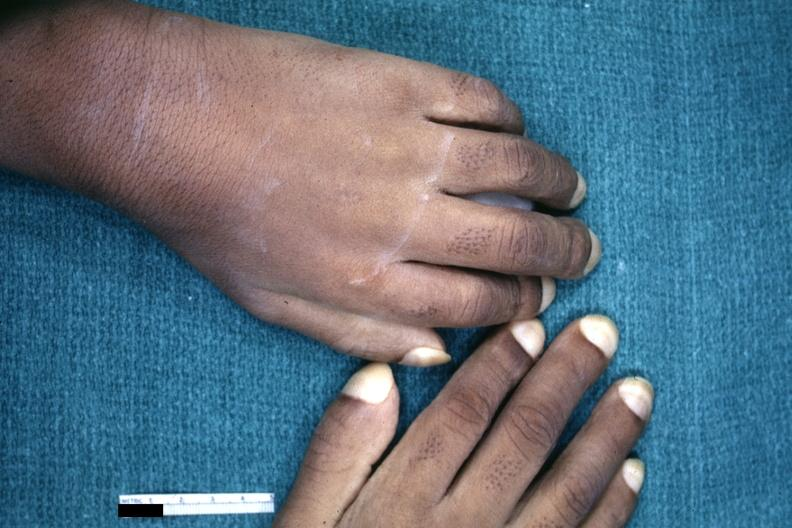what does this image show?
Answer the question using a single word or phrase. Childs hands with obvious clubbing 